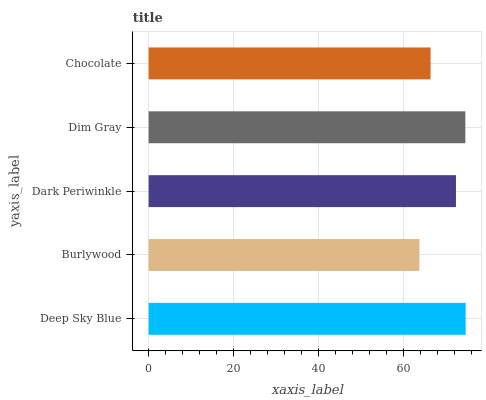Is Burlywood the minimum?
Answer yes or no. Yes. Is Deep Sky Blue the maximum?
Answer yes or no. Yes. Is Dark Periwinkle the minimum?
Answer yes or no. No. Is Dark Periwinkle the maximum?
Answer yes or no. No. Is Dark Periwinkle greater than Burlywood?
Answer yes or no. Yes. Is Burlywood less than Dark Periwinkle?
Answer yes or no. Yes. Is Burlywood greater than Dark Periwinkle?
Answer yes or no. No. Is Dark Periwinkle less than Burlywood?
Answer yes or no. No. Is Dark Periwinkle the high median?
Answer yes or no. Yes. Is Dark Periwinkle the low median?
Answer yes or no. Yes. Is Dim Gray the high median?
Answer yes or no. No. Is Dim Gray the low median?
Answer yes or no. No. 